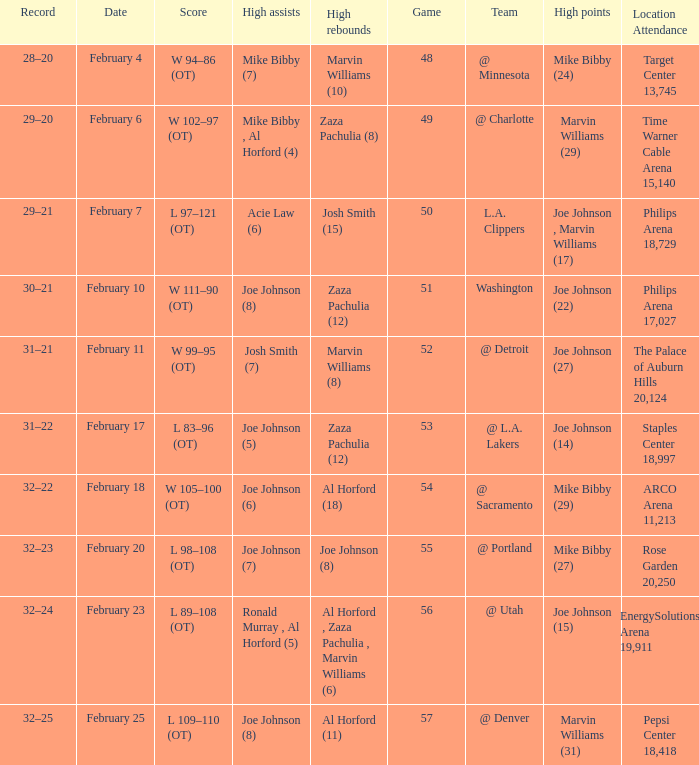How many high assists stats were maade on february 4 1.0. 